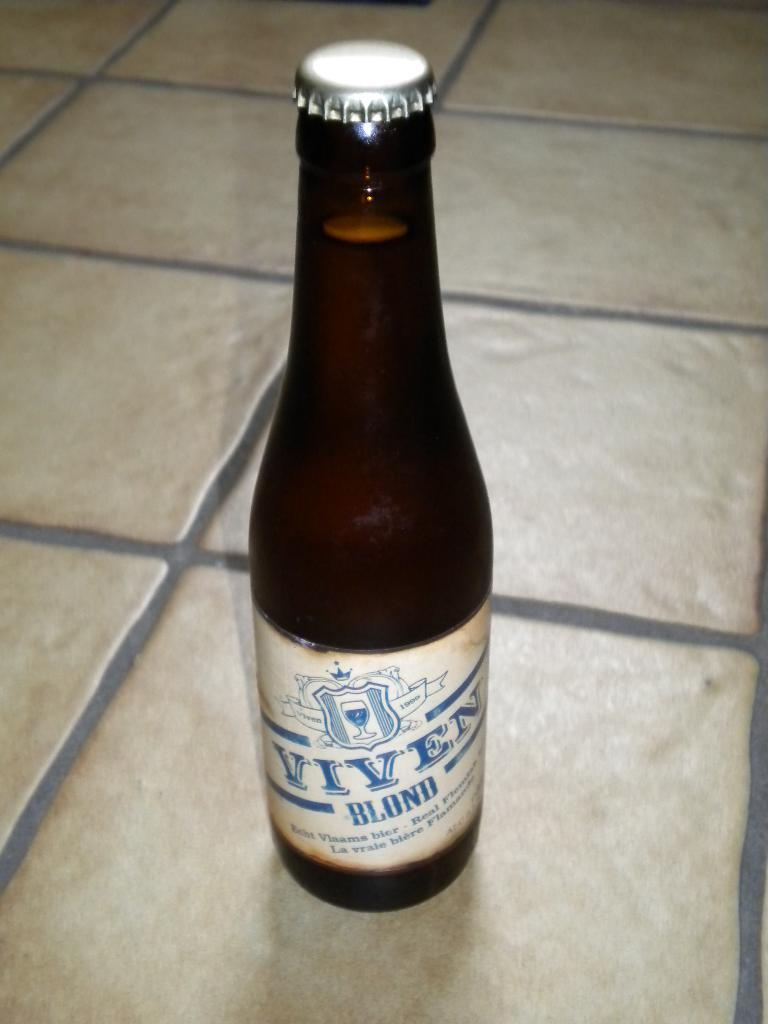<image>
Present a compact description of the photo's key features. A beer bottle of Viven Blond with the bottlecap still on. 